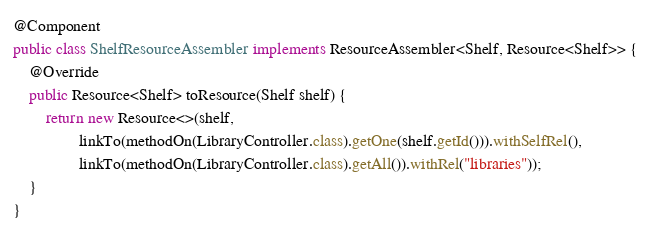<code> <loc_0><loc_0><loc_500><loc_500><_Java_>@Component
public class ShelfResourceAssembler implements ResourceAssembler<Shelf, Resource<Shelf>> {
    @Override
    public Resource<Shelf> toResource(Shelf shelf) {
        return new Resource<>(shelf,
                linkTo(methodOn(LibraryController.class).getOne(shelf.getId())).withSelfRel(),
                linkTo(methodOn(LibraryController.class).getAll()).withRel("libraries"));
    }
}
</code> 